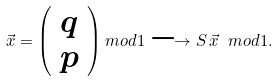Convert formula to latex. <formula><loc_0><loc_0><loc_500><loc_500>\vec { x } = \left ( \begin{array} { c } q \\ p \end{array} \right ) m o d 1 \longrightarrow S \, \vec { x } \ m o d 1 .</formula> 